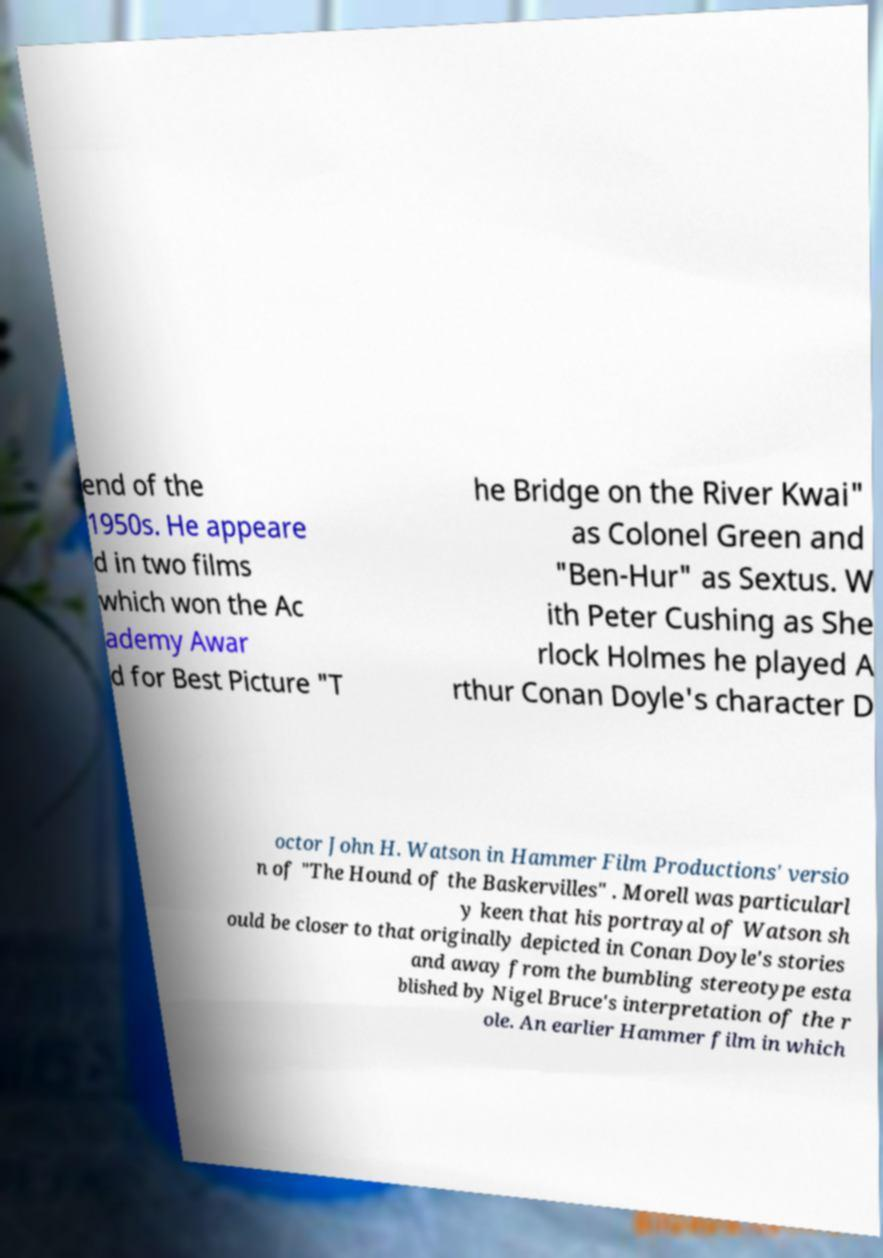I need the written content from this picture converted into text. Can you do that? end of the 1950s. He appeare d in two films which won the Ac ademy Awar d for Best Picture "T he Bridge on the River Kwai" as Colonel Green and "Ben-Hur" as Sextus. W ith Peter Cushing as She rlock Holmes he played A rthur Conan Doyle's character D octor John H. Watson in Hammer Film Productions' versio n of "The Hound of the Baskervilles" . Morell was particularl y keen that his portrayal of Watson sh ould be closer to that originally depicted in Conan Doyle's stories and away from the bumbling stereotype esta blished by Nigel Bruce's interpretation of the r ole. An earlier Hammer film in which 